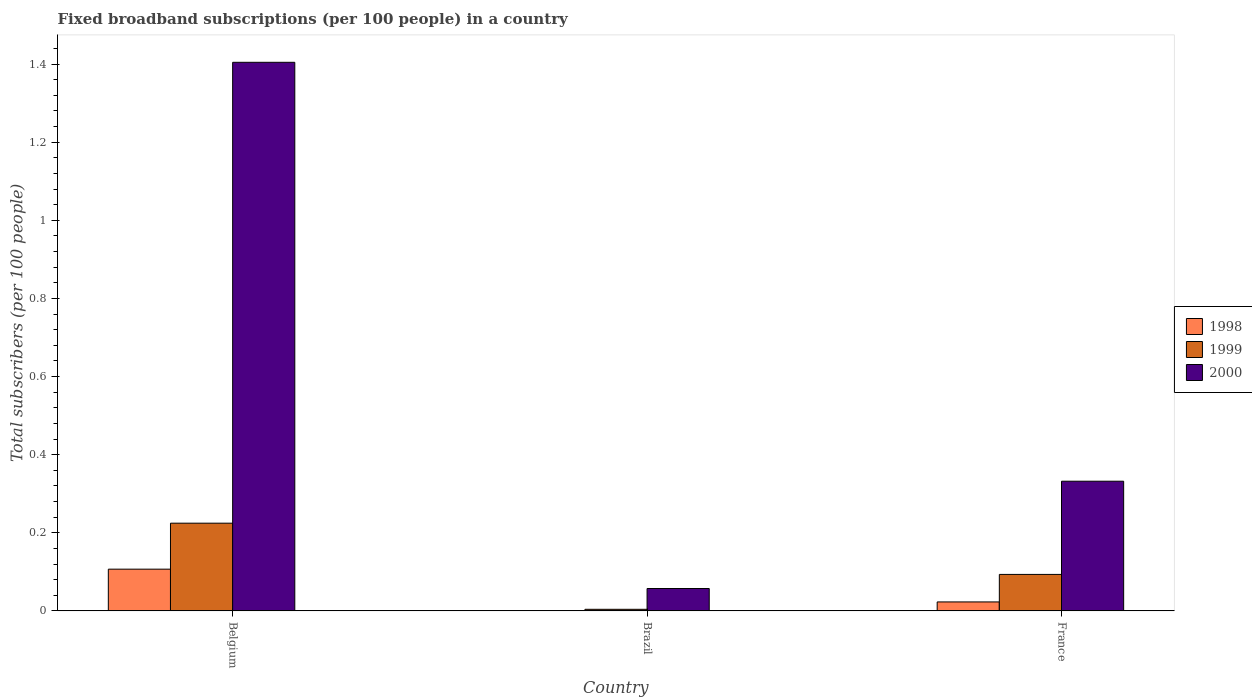How many bars are there on the 1st tick from the left?
Make the answer very short. 3. How many bars are there on the 1st tick from the right?
Your answer should be compact. 3. What is the number of broadband subscriptions in 1999 in France?
Offer a very short reply. 0.09. Across all countries, what is the maximum number of broadband subscriptions in 1998?
Make the answer very short. 0.11. Across all countries, what is the minimum number of broadband subscriptions in 1998?
Your answer should be very brief. 0. What is the total number of broadband subscriptions in 1998 in the graph?
Give a very brief answer. 0.13. What is the difference between the number of broadband subscriptions in 1999 in Brazil and that in France?
Your answer should be compact. -0.09. What is the difference between the number of broadband subscriptions in 1998 in Brazil and the number of broadband subscriptions in 2000 in Belgium?
Offer a very short reply. -1.4. What is the average number of broadband subscriptions in 2000 per country?
Provide a succinct answer. 0.6. What is the difference between the number of broadband subscriptions of/in 1999 and number of broadband subscriptions of/in 1998 in Belgium?
Provide a succinct answer. 0.12. In how many countries, is the number of broadband subscriptions in 1999 greater than 0.28?
Give a very brief answer. 0. What is the ratio of the number of broadband subscriptions in 1999 in Belgium to that in Brazil?
Provide a short and direct response. 55.18. What is the difference between the highest and the second highest number of broadband subscriptions in 2000?
Your response must be concise. -1.07. What is the difference between the highest and the lowest number of broadband subscriptions in 1998?
Your answer should be very brief. 0.11. In how many countries, is the number of broadband subscriptions in 1998 greater than the average number of broadband subscriptions in 1998 taken over all countries?
Offer a terse response. 1. Is the sum of the number of broadband subscriptions in 2000 in Brazil and France greater than the maximum number of broadband subscriptions in 1998 across all countries?
Your answer should be very brief. Yes. What does the 1st bar from the left in France represents?
Offer a very short reply. 1998. Is it the case that in every country, the sum of the number of broadband subscriptions in 1998 and number of broadband subscriptions in 1999 is greater than the number of broadband subscriptions in 2000?
Your answer should be compact. No. Are all the bars in the graph horizontal?
Your answer should be compact. No. What is the difference between two consecutive major ticks on the Y-axis?
Offer a terse response. 0.2. Are the values on the major ticks of Y-axis written in scientific E-notation?
Offer a very short reply. No. Does the graph contain any zero values?
Provide a succinct answer. No. Does the graph contain grids?
Offer a terse response. No. What is the title of the graph?
Your answer should be very brief. Fixed broadband subscriptions (per 100 people) in a country. What is the label or title of the X-axis?
Offer a very short reply. Country. What is the label or title of the Y-axis?
Give a very brief answer. Total subscribers (per 100 people). What is the Total subscribers (per 100 people) of 1998 in Belgium?
Offer a very short reply. 0.11. What is the Total subscribers (per 100 people) of 1999 in Belgium?
Provide a succinct answer. 0.22. What is the Total subscribers (per 100 people) of 2000 in Belgium?
Provide a succinct answer. 1.4. What is the Total subscribers (per 100 people) in 1998 in Brazil?
Your response must be concise. 0. What is the Total subscribers (per 100 people) of 1999 in Brazil?
Keep it short and to the point. 0. What is the Total subscribers (per 100 people) of 2000 in Brazil?
Provide a short and direct response. 0.06. What is the Total subscribers (per 100 people) in 1998 in France?
Offer a terse response. 0.02. What is the Total subscribers (per 100 people) in 1999 in France?
Give a very brief answer. 0.09. What is the Total subscribers (per 100 people) of 2000 in France?
Offer a very short reply. 0.33. Across all countries, what is the maximum Total subscribers (per 100 people) in 1998?
Your answer should be compact. 0.11. Across all countries, what is the maximum Total subscribers (per 100 people) in 1999?
Ensure brevity in your answer.  0.22. Across all countries, what is the maximum Total subscribers (per 100 people) of 2000?
Keep it short and to the point. 1.4. Across all countries, what is the minimum Total subscribers (per 100 people) in 1998?
Give a very brief answer. 0. Across all countries, what is the minimum Total subscribers (per 100 people) in 1999?
Keep it short and to the point. 0. Across all countries, what is the minimum Total subscribers (per 100 people) of 2000?
Provide a short and direct response. 0.06. What is the total Total subscribers (per 100 people) in 1998 in the graph?
Your response must be concise. 0.13. What is the total Total subscribers (per 100 people) in 1999 in the graph?
Your response must be concise. 0.32. What is the total Total subscribers (per 100 people) in 2000 in the graph?
Your response must be concise. 1.79. What is the difference between the Total subscribers (per 100 people) of 1998 in Belgium and that in Brazil?
Your answer should be very brief. 0.11. What is the difference between the Total subscribers (per 100 people) in 1999 in Belgium and that in Brazil?
Offer a very short reply. 0.22. What is the difference between the Total subscribers (per 100 people) in 2000 in Belgium and that in Brazil?
Your answer should be compact. 1.35. What is the difference between the Total subscribers (per 100 people) of 1998 in Belgium and that in France?
Offer a terse response. 0.08. What is the difference between the Total subscribers (per 100 people) in 1999 in Belgium and that in France?
Ensure brevity in your answer.  0.13. What is the difference between the Total subscribers (per 100 people) of 2000 in Belgium and that in France?
Make the answer very short. 1.07. What is the difference between the Total subscribers (per 100 people) in 1998 in Brazil and that in France?
Provide a short and direct response. -0.02. What is the difference between the Total subscribers (per 100 people) of 1999 in Brazil and that in France?
Keep it short and to the point. -0.09. What is the difference between the Total subscribers (per 100 people) of 2000 in Brazil and that in France?
Provide a short and direct response. -0.27. What is the difference between the Total subscribers (per 100 people) of 1998 in Belgium and the Total subscribers (per 100 people) of 1999 in Brazil?
Ensure brevity in your answer.  0.1. What is the difference between the Total subscribers (per 100 people) of 1998 in Belgium and the Total subscribers (per 100 people) of 2000 in Brazil?
Give a very brief answer. 0.05. What is the difference between the Total subscribers (per 100 people) of 1999 in Belgium and the Total subscribers (per 100 people) of 2000 in Brazil?
Keep it short and to the point. 0.17. What is the difference between the Total subscribers (per 100 people) in 1998 in Belgium and the Total subscribers (per 100 people) in 1999 in France?
Ensure brevity in your answer.  0.01. What is the difference between the Total subscribers (per 100 people) of 1998 in Belgium and the Total subscribers (per 100 people) of 2000 in France?
Ensure brevity in your answer.  -0.23. What is the difference between the Total subscribers (per 100 people) of 1999 in Belgium and the Total subscribers (per 100 people) of 2000 in France?
Ensure brevity in your answer.  -0.11. What is the difference between the Total subscribers (per 100 people) of 1998 in Brazil and the Total subscribers (per 100 people) of 1999 in France?
Ensure brevity in your answer.  -0.09. What is the difference between the Total subscribers (per 100 people) in 1998 in Brazil and the Total subscribers (per 100 people) in 2000 in France?
Make the answer very short. -0.33. What is the difference between the Total subscribers (per 100 people) in 1999 in Brazil and the Total subscribers (per 100 people) in 2000 in France?
Make the answer very short. -0.33. What is the average Total subscribers (per 100 people) of 1998 per country?
Provide a succinct answer. 0.04. What is the average Total subscribers (per 100 people) of 1999 per country?
Ensure brevity in your answer.  0.11. What is the average Total subscribers (per 100 people) in 2000 per country?
Offer a very short reply. 0.6. What is the difference between the Total subscribers (per 100 people) in 1998 and Total subscribers (per 100 people) in 1999 in Belgium?
Provide a succinct answer. -0.12. What is the difference between the Total subscribers (per 100 people) in 1998 and Total subscribers (per 100 people) in 2000 in Belgium?
Your answer should be compact. -1.3. What is the difference between the Total subscribers (per 100 people) of 1999 and Total subscribers (per 100 people) of 2000 in Belgium?
Give a very brief answer. -1.18. What is the difference between the Total subscribers (per 100 people) of 1998 and Total subscribers (per 100 people) of 1999 in Brazil?
Offer a terse response. -0. What is the difference between the Total subscribers (per 100 people) of 1998 and Total subscribers (per 100 people) of 2000 in Brazil?
Make the answer very short. -0.06. What is the difference between the Total subscribers (per 100 people) in 1999 and Total subscribers (per 100 people) in 2000 in Brazil?
Provide a short and direct response. -0.05. What is the difference between the Total subscribers (per 100 people) in 1998 and Total subscribers (per 100 people) in 1999 in France?
Your answer should be very brief. -0.07. What is the difference between the Total subscribers (per 100 people) of 1998 and Total subscribers (per 100 people) of 2000 in France?
Your answer should be very brief. -0.31. What is the difference between the Total subscribers (per 100 people) of 1999 and Total subscribers (per 100 people) of 2000 in France?
Offer a very short reply. -0.24. What is the ratio of the Total subscribers (per 100 people) of 1998 in Belgium to that in Brazil?
Your response must be concise. 181.1. What is the ratio of the Total subscribers (per 100 people) of 1999 in Belgium to that in Brazil?
Ensure brevity in your answer.  55.18. What is the ratio of the Total subscribers (per 100 people) of 2000 in Belgium to that in Brazil?
Provide a succinct answer. 24.51. What is the ratio of the Total subscribers (per 100 people) of 1998 in Belgium to that in France?
Offer a very short reply. 4.65. What is the ratio of the Total subscribers (per 100 people) in 1999 in Belgium to that in France?
Your response must be concise. 2.4. What is the ratio of the Total subscribers (per 100 people) in 2000 in Belgium to that in France?
Make the answer very short. 4.23. What is the ratio of the Total subscribers (per 100 people) in 1998 in Brazil to that in France?
Keep it short and to the point. 0.03. What is the ratio of the Total subscribers (per 100 people) of 1999 in Brazil to that in France?
Keep it short and to the point. 0.04. What is the ratio of the Total subscribers (per 100 people) of 2000 in Brazil to that in France?
Provide a short and direct response. 0.17. What is the difference between the highest and the second highest Total subscribers (per 100 people) in 1998?
Your response must be concise. 0.08. What is the difference between the highest and the second highest Total subscribers (per 100 people) in 1999?
Offer a very short reply. 0.13. What is the difference between the highest and the second highest Total subscribers (per 100 people) of 2000?
Your answer should be very brief. 1.07. What is the difference between the highest and the lowest Total subscribers (per 100 people) in 1998?
Provide a short and direct response. 0.11. What is the difference between the highest and the lowest Total subscribers (per 100 people) of 1999?
Make the answer very short. 0.22. What is the difference between the highest and the lowest Total subscribers (per 100 people) of 2000?
Keep it short and to the point. 1.35. 